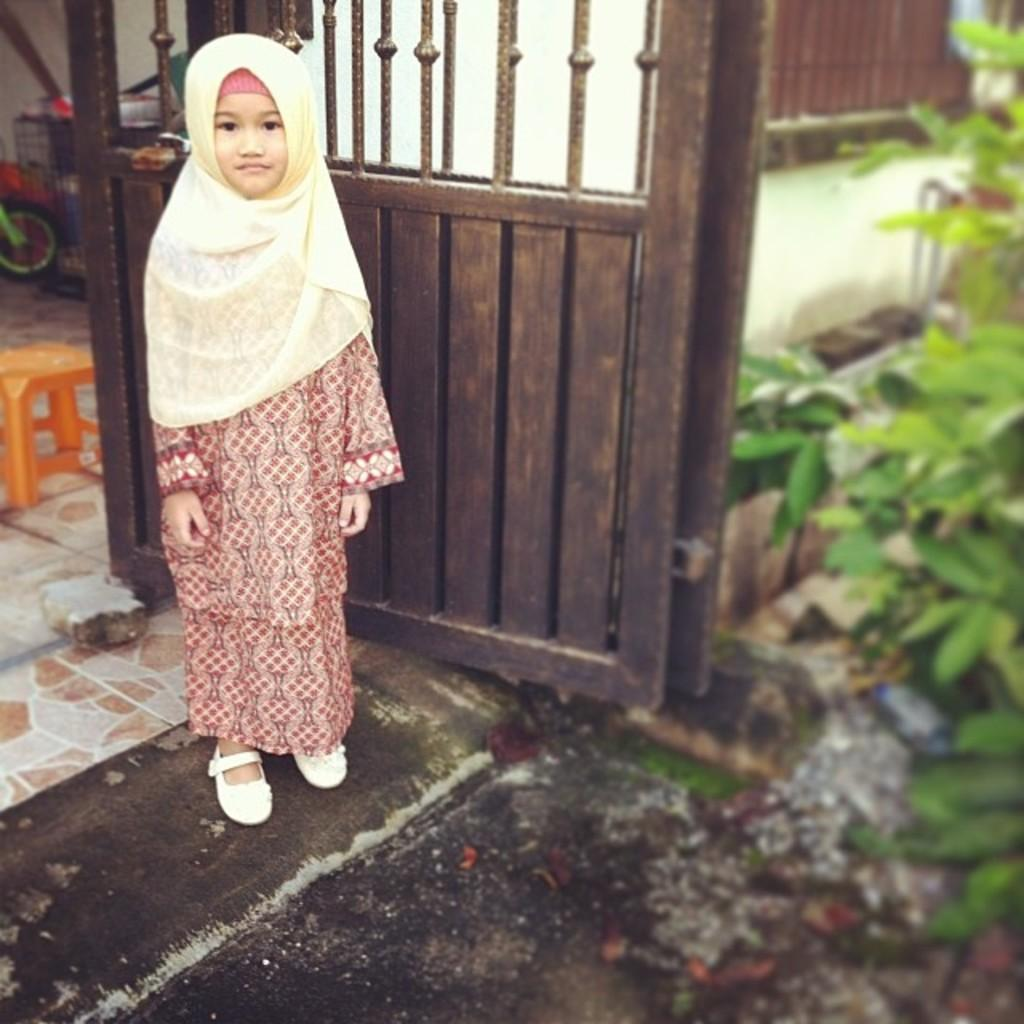Who is the main subject in the image? There is a girl in the image. What is the girl doing in the image? The girl is standing on the ground. What can be seen in the background of the image? There is a gate, a wall, plants, and some objects in the background of the image. What type of coat is the girl wearing in the image? There is no coat visible in the image; the girl is not wearing any outerwear. What is the condition of the girl's toe in the image? There is no indication of the girl's toe in the image, as it is not visible or mentioned in the provided facts. 